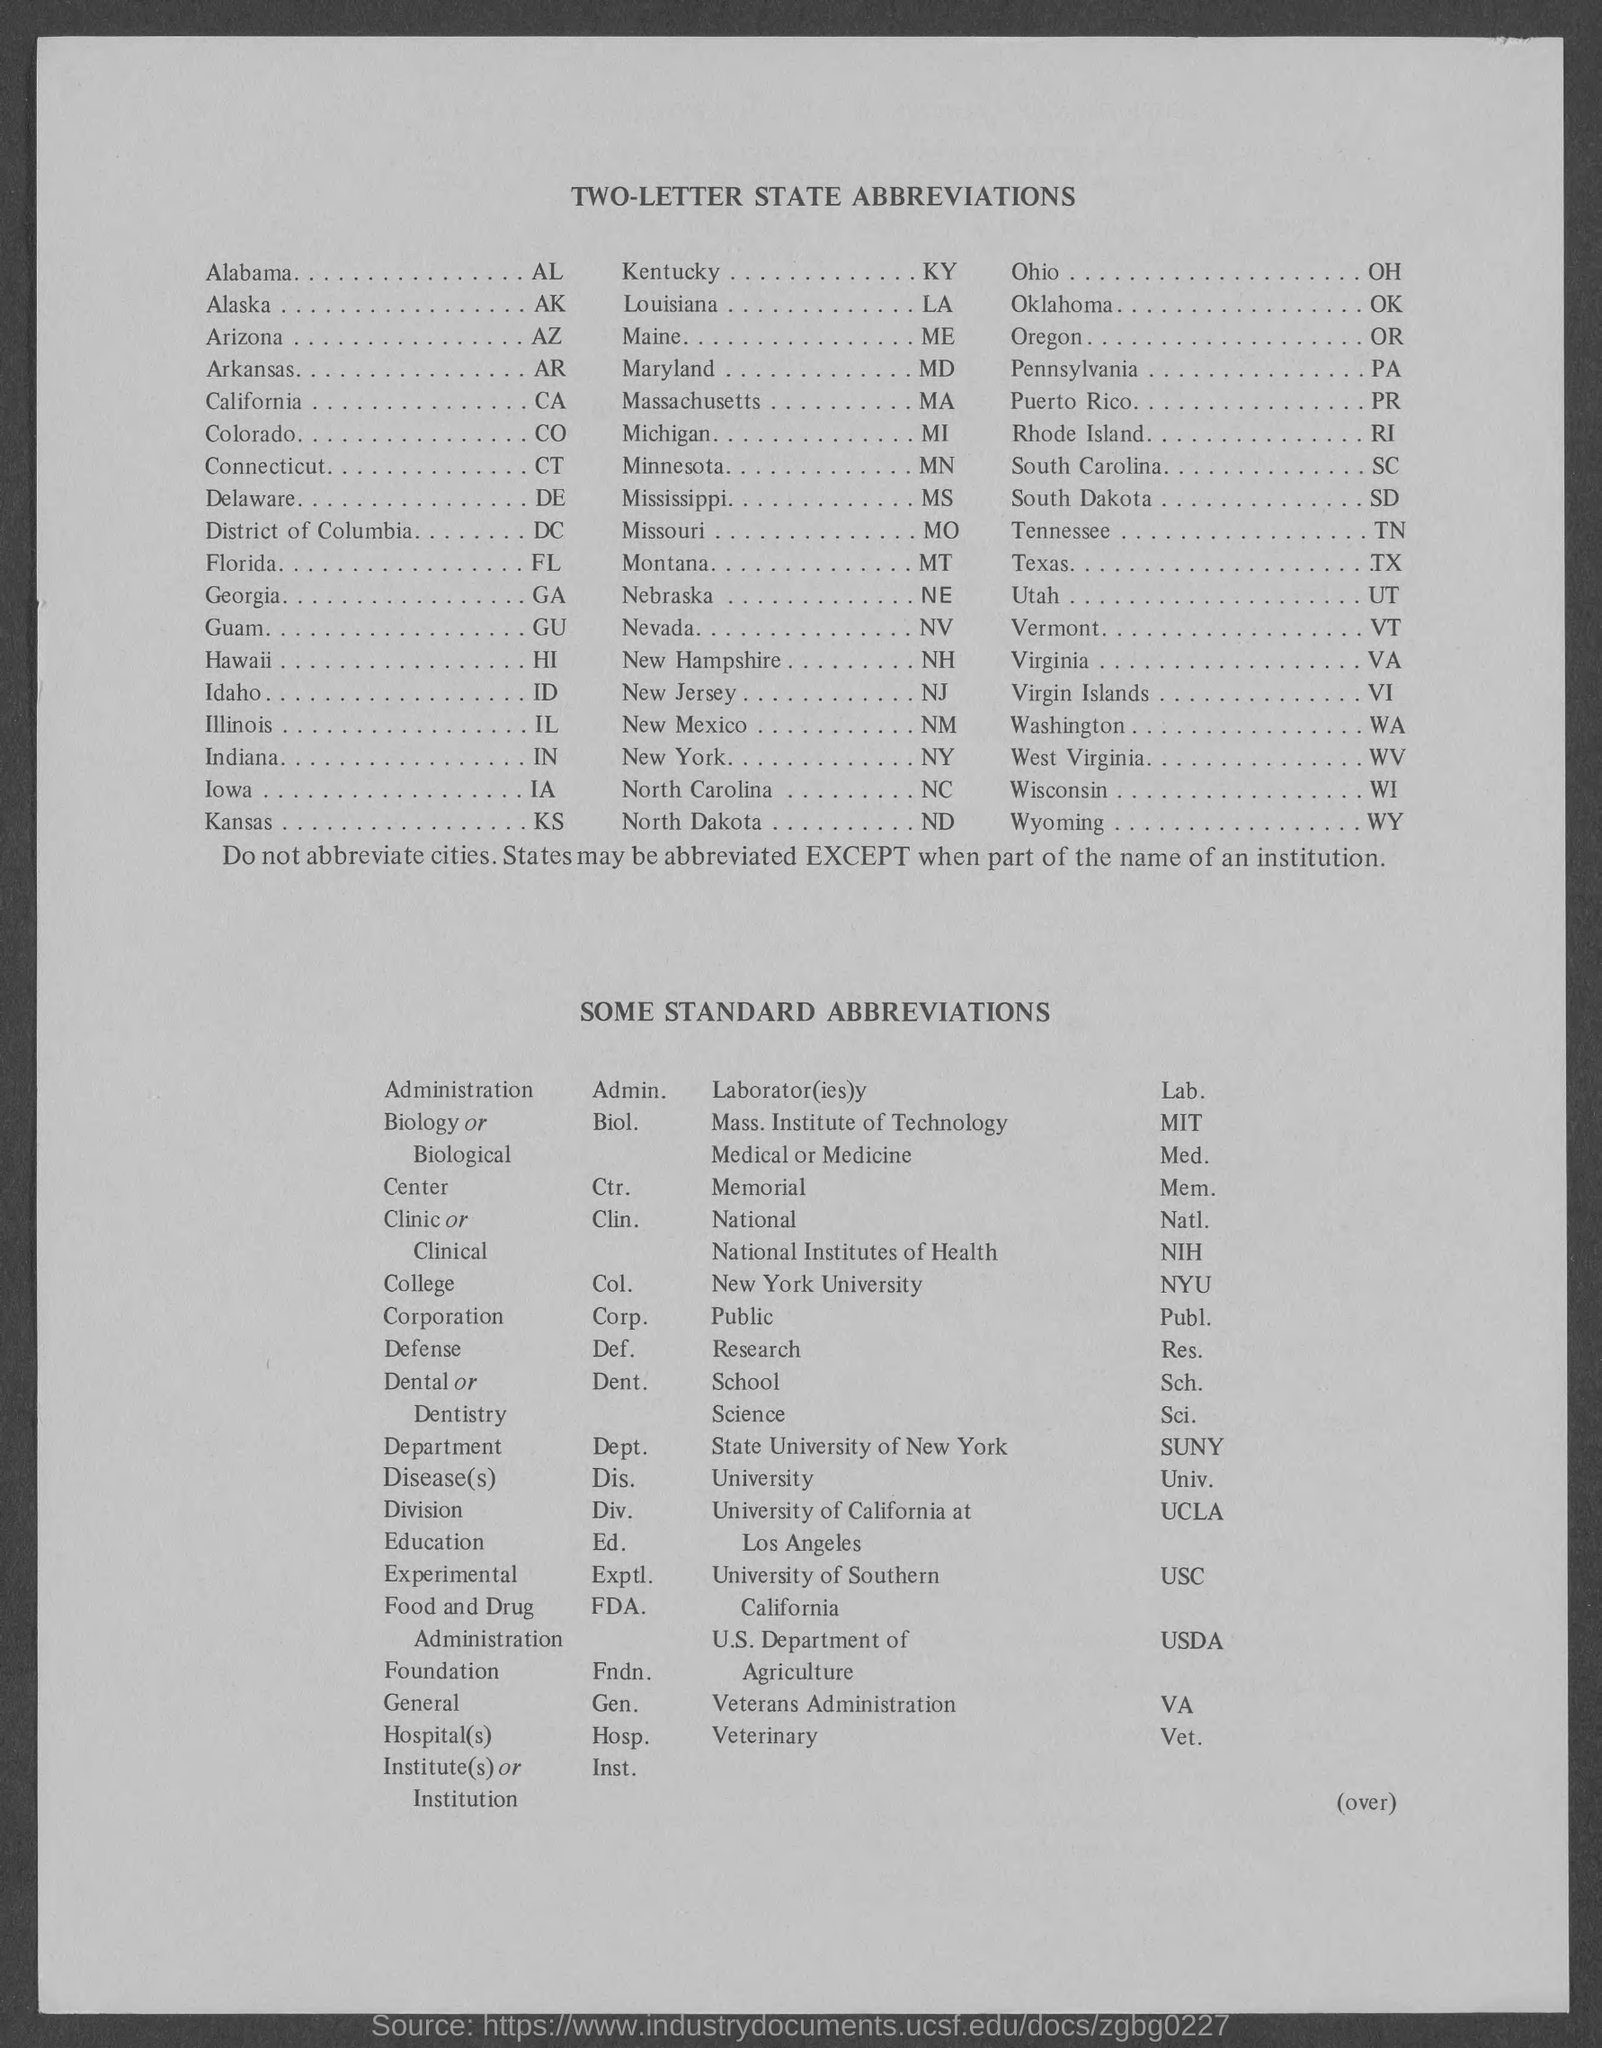What do the abbreviations 'GU' and 'PR' stand for? The abbreviation 'GU' stands for Guam, and 'PR' stands for Puerto Rico. Both territories have unique cultures and histories, and they are included in the list of two-letter state abbreviations for ease of reference in various official contexts.  Are there any abbreviations that are not related to U.S. states or territories? Yes, the list includes abbreviations for well-known institutions and terms. For example, 'MIT' stands for Massachusetts Institute of Technology, 'USDA' stands for U.S. Department of Agriculture, and 'FDA' refers to Food and Drug Administration. These abbreviations help to streamline communication and documentation. 